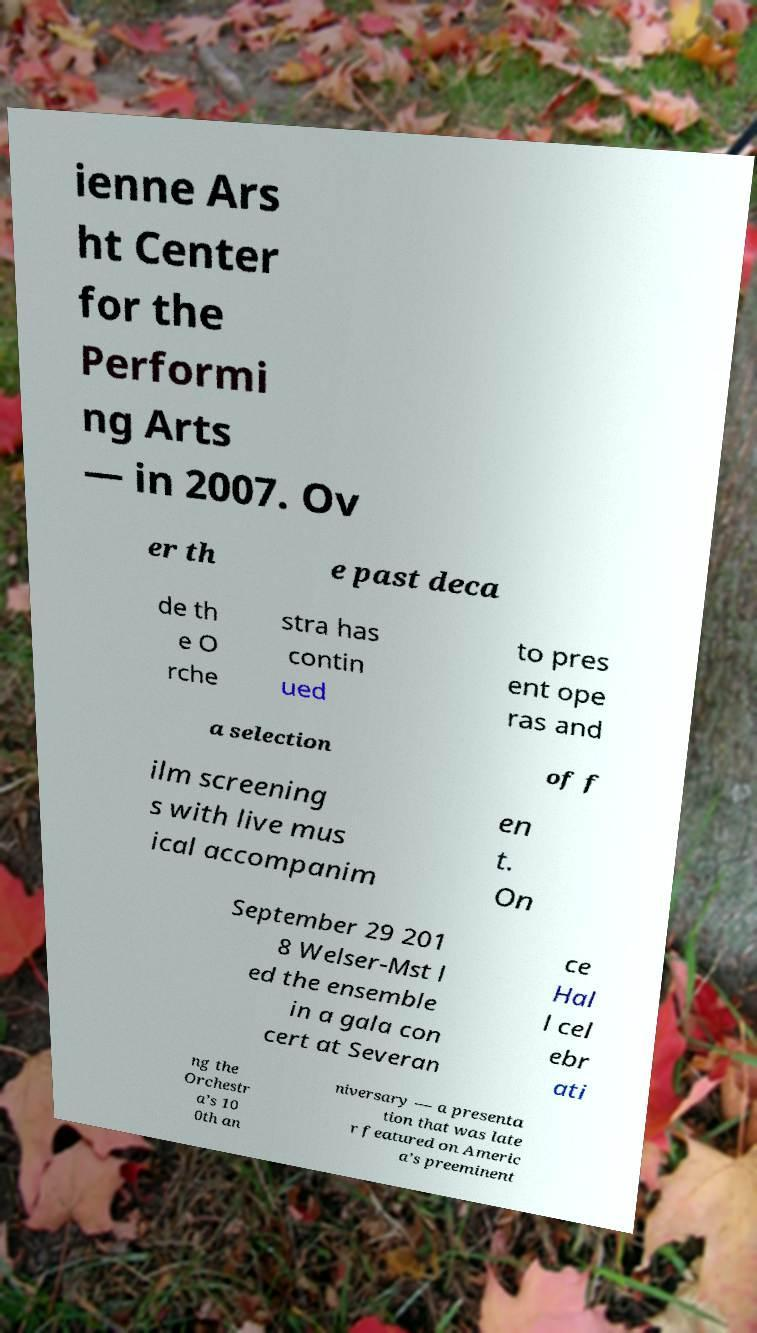For documentation purposes, I need the text within this image transcribed. Could you provide that? ienne Ars ht Center for the Performi ng Arts — in 2007. Ov er th e past deca de th e O rche stra has contin ued to pres ent ope ras and a selection of f ilm screening s with live mus ical accompanim en t. On September 29 201 8 Welser-Mst l ed the ensemble in a gala con cert at Severan ce Hal l cel ebr ati ng the Orchestr a’s 10 0th an niversary — a presenta tion that was late r featured on Americ a’s preeminent 